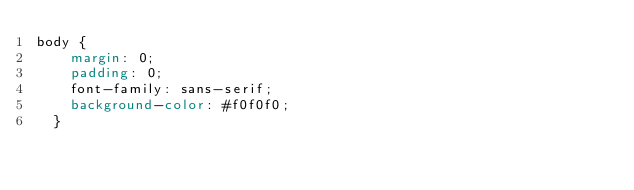Convert code to text. <code><loc_0><loc_0><loc_500><loc_500><_CSS_>body {
    margin: 0;
    padding: 0;
    font-family: sans-serif;
    background-color: #f0f0f0;
  }
  </code> 